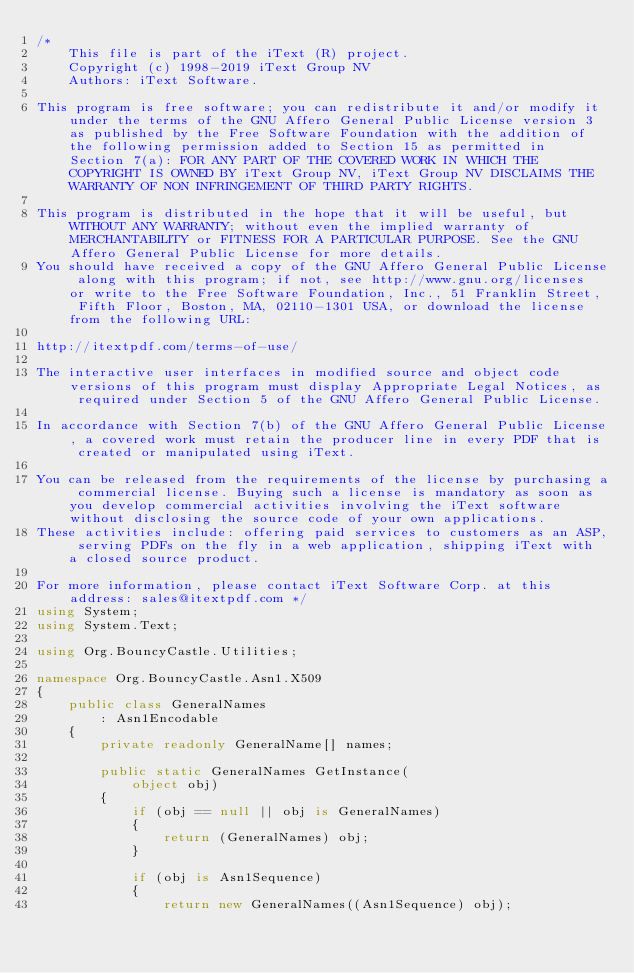<code> <loc_0><loc_0><loc_500><loc_500><_C#_>/*
    This file is part of the iText (R) project.
    Copyright (c) 1998-2019 iText Group NV
    Authors: iText Software.

This program is free software; you can redistribute it and/or modify it under the terms of the GNU Affero General Public License version 3 as published by the Free Software Foundation with the addition of the following permission added to Section 15 as permitted in Section 7(a): FOR ANY PART OF THE COVERED WORK IN WHICH THE COPYRIGHT IS OWNED BY iText Group NV, iText Group NV DISCLAIMS THE WARRANTY OF NON INFRINGEMENT OF THIRD PARTY RIGHTS.

This program is distributed in the hope that it will be useful, but WITHOUT ANY WARRANTY; without even the implied warranty of MERCHANTABILITY or FITNESS FOR A PARTICULAR PURPOSE. See the GNU Affero General Public License for more details.
You should have received a copy of the GNU Affero General Public License along with this program; if not, see http://www.gnu.org/licenses or write to the Free Software Foundation, Inc., 51 Franklin Street, Fifth Floor, Boston, MA, 02110-1301 USA, or download the license from the following URL:

http://itextpdf.com/terms-of-use/

The interactive user interfaces in modified source and object code versions of this program must display Appropriate Legal Notices, as required under Section 5 of the GNU Affero General Public License.

In accordance with Section 7(b) of the GNU Affero General Public License, a covered work must retain the producer line in every PDF that is created or manipulated using iText.

You can be released from the requirements of the license by purchasing a commercial license. Buying such a license is mandatory as soon as you develop commercial activities involving the iText software without disclosing the source code of your own applications.
These activities include: offering paid services to customers as an ASP, serving PDFs on the fly in a web application, shipping iText with a closed source product.

For more information, please contact iText Software Corp. at this address: sales@itextpdf.com */
using System;
using System.Text;

using Org.BouncyCastle.Utilities;

namespace Org.BouncyCastle.Asn1.X509
{
	public class GeneralNames
		: Asn1Encodable
	{
		private readonly GeneralName[] names;

		public static GeneralNames GetInstance(
			object obj)
		{
			if (obj == null || obj is GeneralNames)
			{
				return (GeneralNames) obj;
			}

			if (obj is Asn1Sequence)
			{
				return new GeneralNames((Asn1Sequence) obj);</code> 